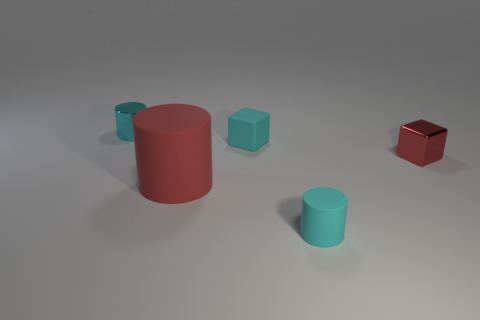Subtract all cyan shiny cylinders. How many cylinders are left? 2 Subtract all red cubes. How many cubes are left? 1 Subtract 1 blocks. How many blocks are left? 1 Add 3 small shiny blocks. How many objects exist? 8 Subtract all brown blocks. How many cyan cylinders are left? 2 Subtract all blocks. How many objects are left? 3 Subtract all green cylinders. Subtract all red blocks. How many cylinders are left? 3 Subtract all small red shiny things. Subtract all tiny metallic blocks. How many objects are left? 3 Add 3 big cylinders. How many big cylinders are left? 4 Add 5 big purple balls. How many big purple balls exist? 5 